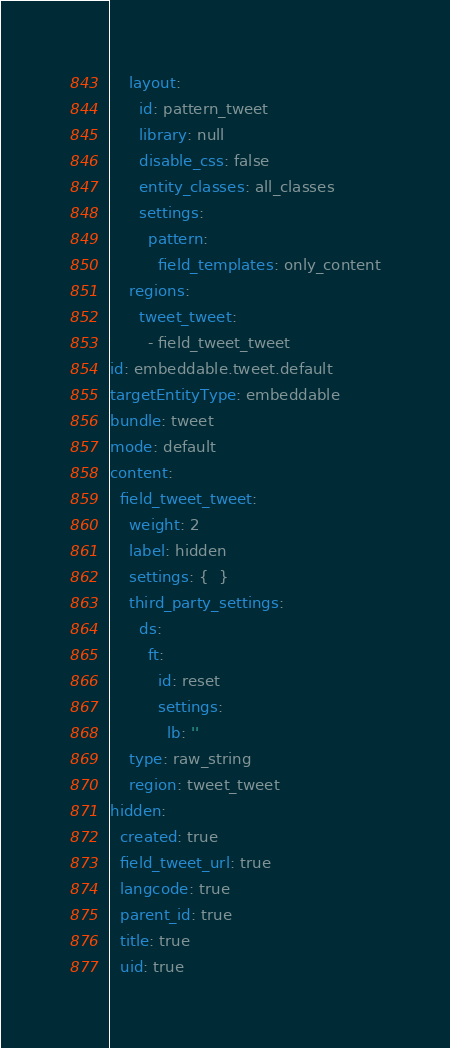Convert code to text. <code><loc_0><loc_0><loc_500><loc_500><_YAML_>    layout:
      id: pattern_tweet
      library: null
      disable_css: false
      entity_classes: all_classes
      settings:
        pattern:
          field_templates: only_content
    regions:
      tweet_tweet:
        - field_tweet_tweet
id: embeddable.tweet.default
targetEntityType: embeddable
bundle: tweet
mode: default
content:
  field_tweet_tweet:
    weight: 2
    label: hidden
    settings: {  }
    third_party_settings:
      ds:
        ft:
          id: reset
          settings:
            lb: ''
    type: raw_string
    region: tweet_tweet
hidden:
  created: true
  field_tweet_url: true
  langcode: true
  parent_id: true
  title: true
  uid: true
</code> 